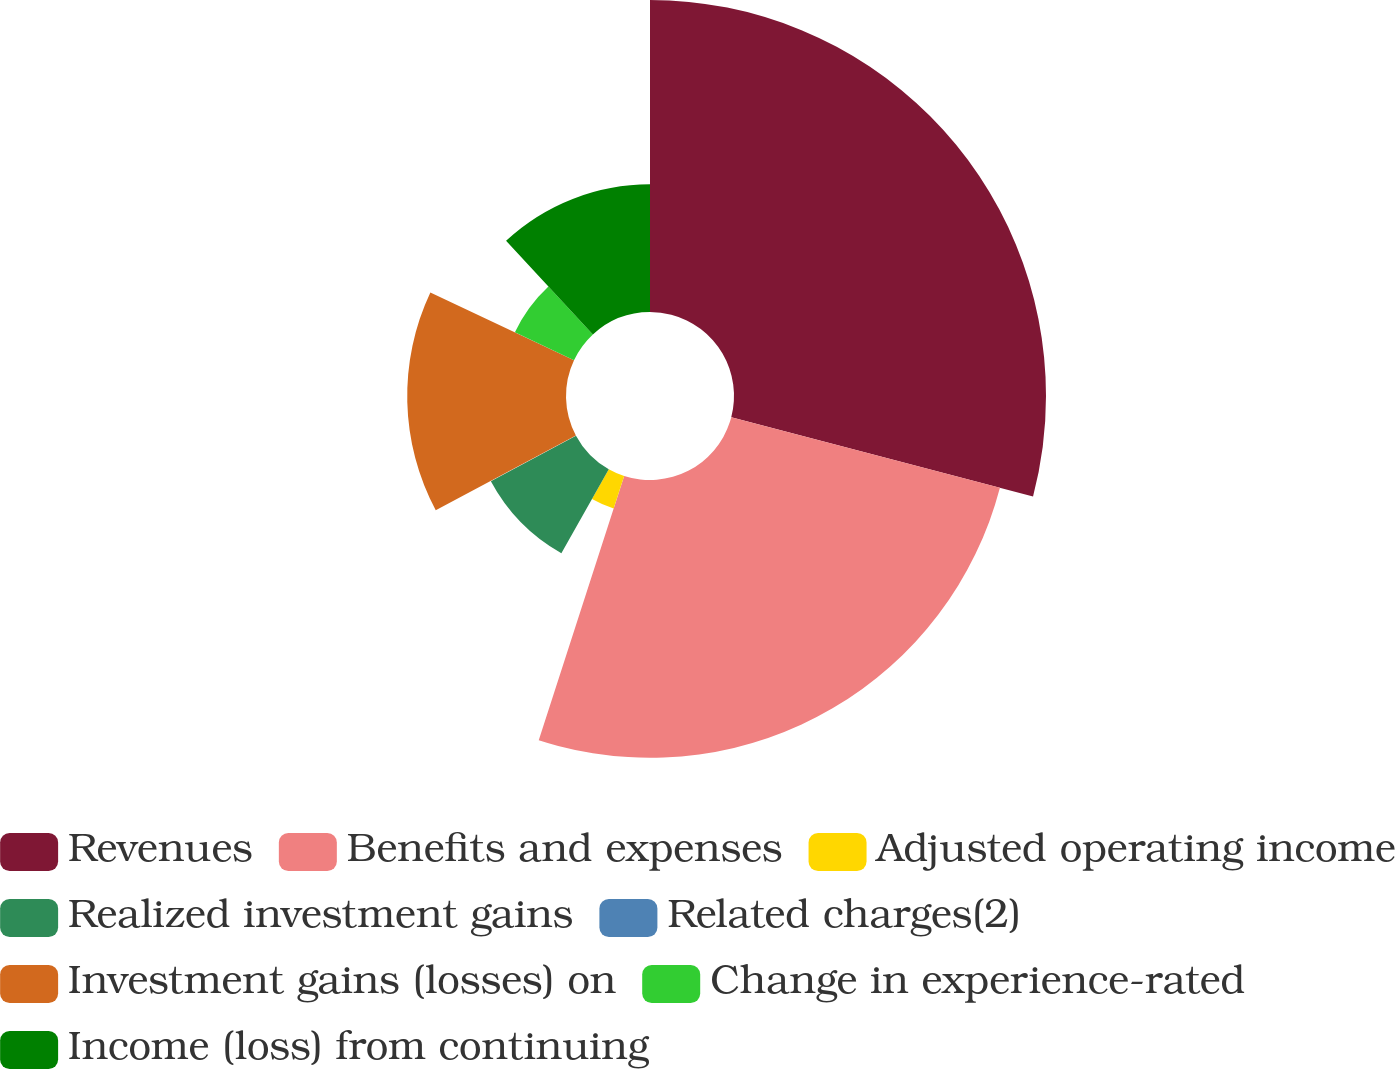Convert chart. <chart><loc_0><loc_0><loc_500><loc_500><pie_chart><fcel>Revenues<fcel>Benefits and expenses<fcel>Adjusted operating income<fcel>Realized investment gains<fcel>Related charges(2)<fcel>Investment gains (losses) on<fcel>Change in experience-rated<fcel>Income (loss) from continuing<nl><fcel>29.08%<fcel>25.89%<fcel>3.19%<fcel>9.0%<fcel>0.04%<fcel>14.8%<fcel>6.09%<fcel>11.9%<nl></chart> 